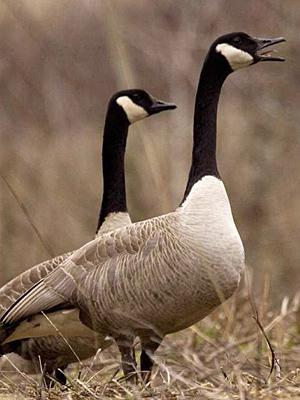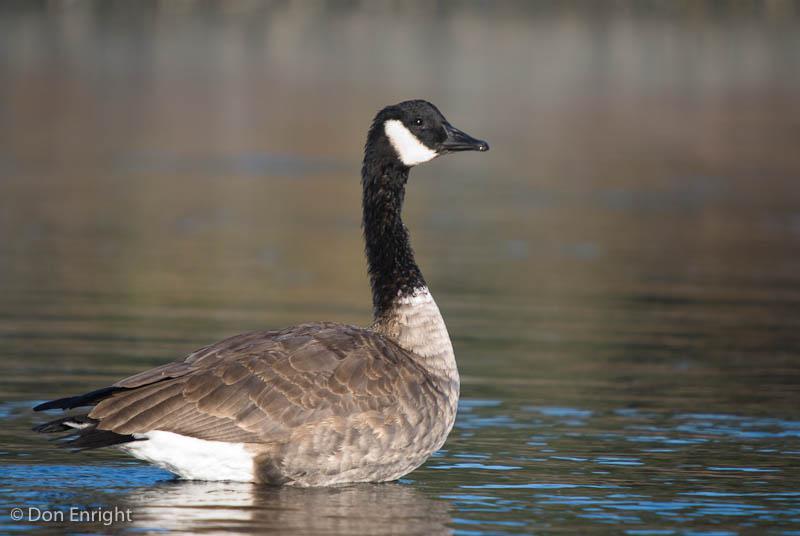The first image is the image on the left, the second image is the image on the right. Given the left and right images, does the statement "All the ducks in the image are facing the same direction." hold true? Answer yes or no. Yes. 